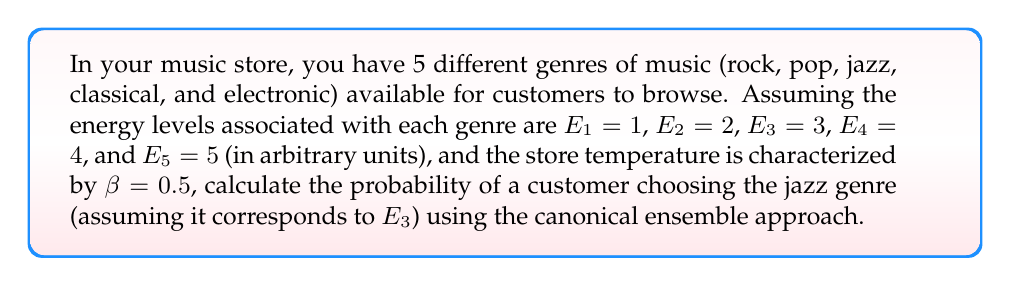Show me your answer to this math problem. To solve this problem, we'll use the canonical ensemble approach:

1. The probability of a system being in a state with energy $E_i$ is given by:
   
   $$P_i = \frac{e^{-\beta E_i}}{Z}$$

   where $Z$ is the partition function.

2. Calculate the partition function $Z$:
   
   $$Z = \sum_{i=1}^5 e^{-\beta E_i}$$
   
   $$Z = e^{-0.5 \cdot 1} + e^{-0.5 \cdot 2} + e^{-0.5 \cdot 3} + e^{-0.5 \cdot 4} + e^{-0.5 \cdot 5}$$
   
   $$Z = e^{-0.5} + e^{-1} + e^{-1.5} + e^{-2} + e^{-2.5}$$
   
   $$Z \approx 0.6065 + 0.3679 + 0.2231 + 0.1353 + 0.0821 \approx 1.4149$$

3. Calculate the probability for the jazz genre ($E_3$):
   
   $$P_3 = \frac{e^{-\beta E_3}}{Z} = \frac{e^{-0.5 \cdot 3}}{1.4149} = \frac{e^{-1.5}}{1.4149} \approx \frac{0.2231}{1.4149} \approx 0.1577$$

4. Convert to a percentage:
   
   $$0.1577 \times 100\% \approx 15.77\%$$
Answer: 15.77% 